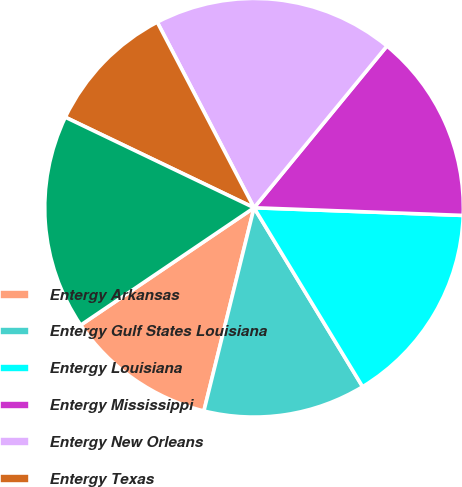Convert chart to OTSL. <chart><loc_0><loc_0><loc_500><loc_500><pie_chart><fcel>Entergy Arkansas<fcel>Entergy Gulf States Louisiana<fcel>Entergy Louisiana<fcel>Entergy Mississippi<fcel>Entergy New Orleans<fcel>Entergy Texas<fcel>System Energy<nl><fcel>11.68%<fcel>12.53%<fcel>15.74%<fcel>14.64%<fcel>18.6%<fcel>10.23%<fcel>16.59%<nl></chart> 